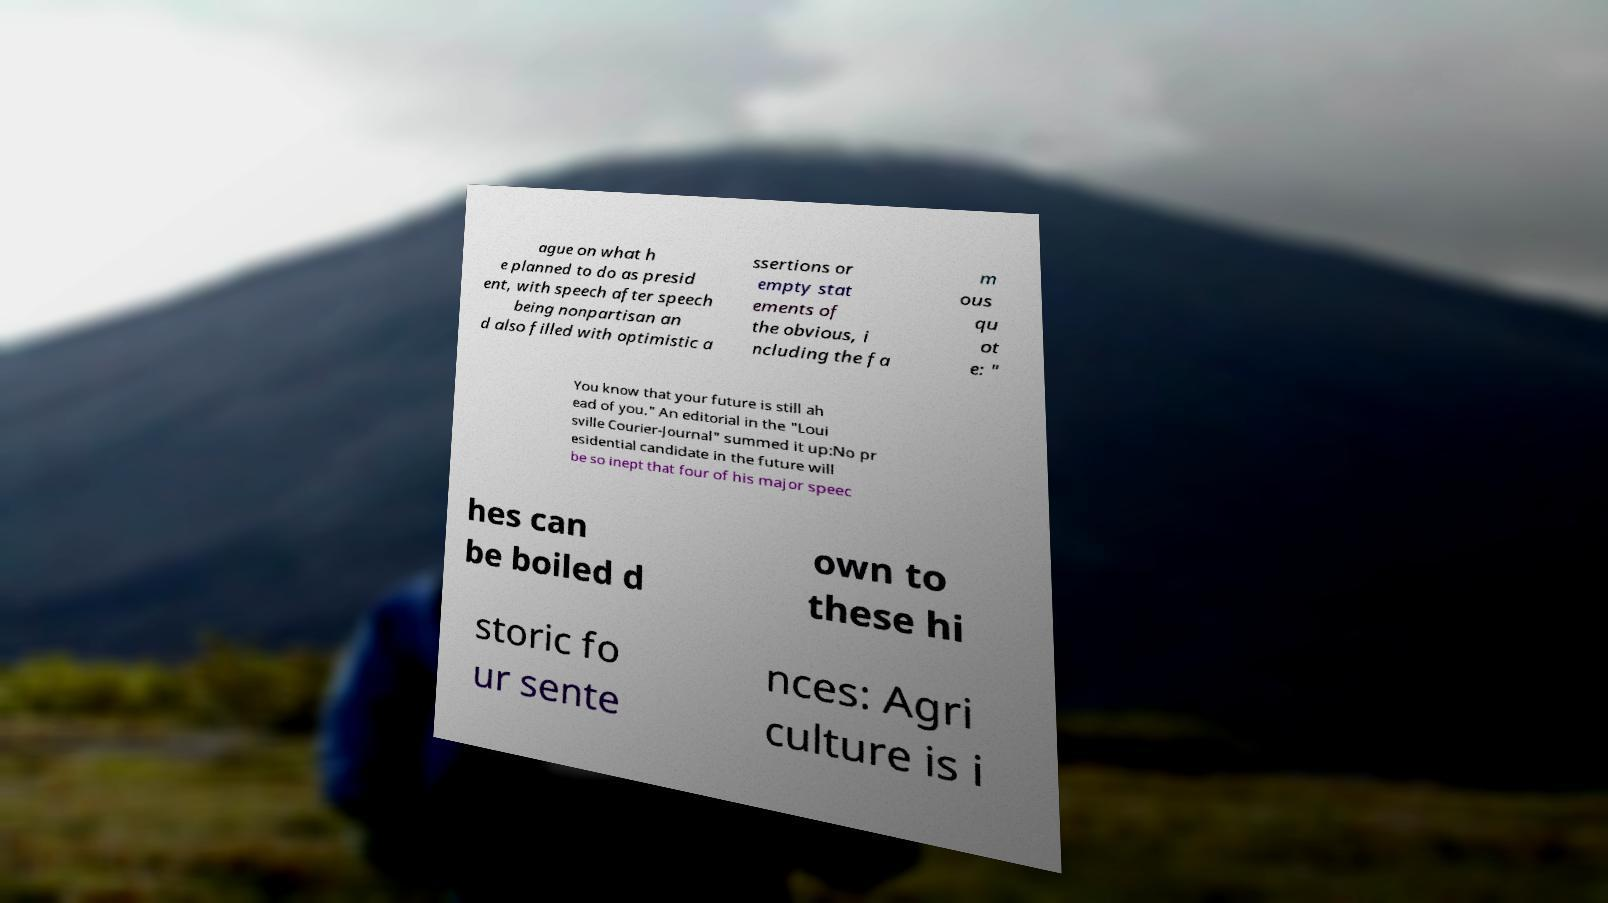What messages or text are displayed in this image? I need them in a readable, typed format. ague on what h e planned to do as presid ent, with speech after speech being nonpartisan an d also filled with optimistic a ssertions or empty stat ements of the obvious, i ncluding the fa m ous qu ot e: " You know that your future is still ah ead of you." An editorial in the "Loui sville Courier-Journal" summed it up:No pr esidential candidate in the future will be so inept that four of his major speec hes can be boiled d own to these hi storic fo ur sente nces: Agri culture is i 